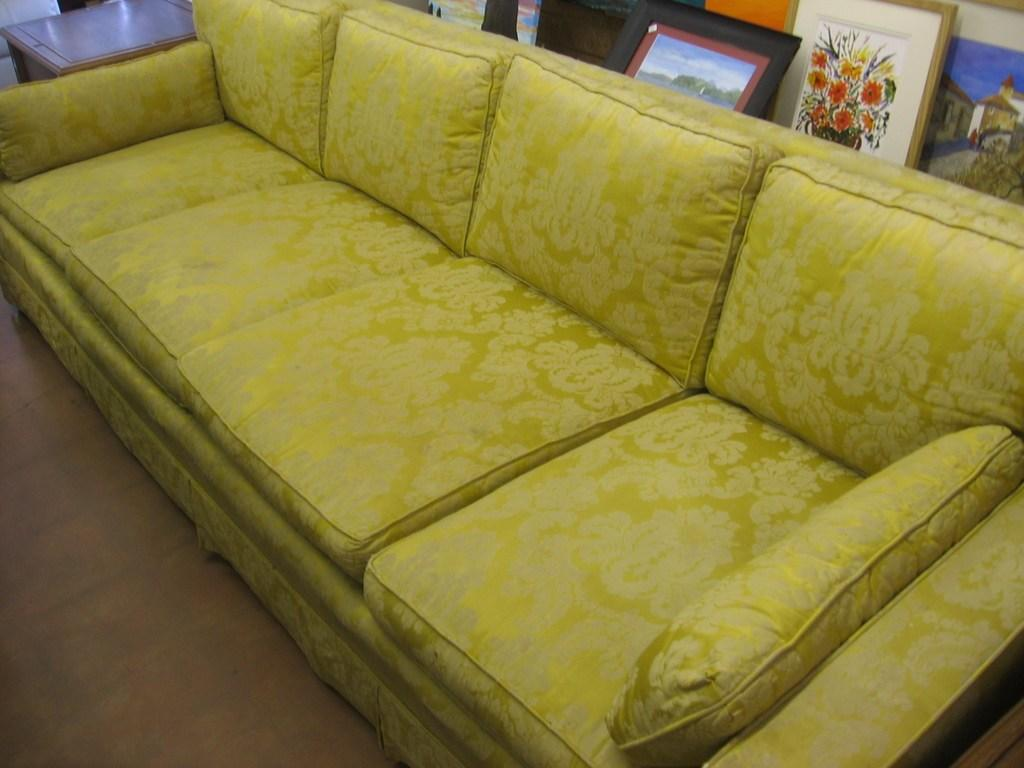What type of furniture is present in the image? There is a sofa in the image. What color is the sofa? The sofa is yellow in color. What is the rate of the twist in the image? There is no twist present in the image, as it features a yellow sofa. 